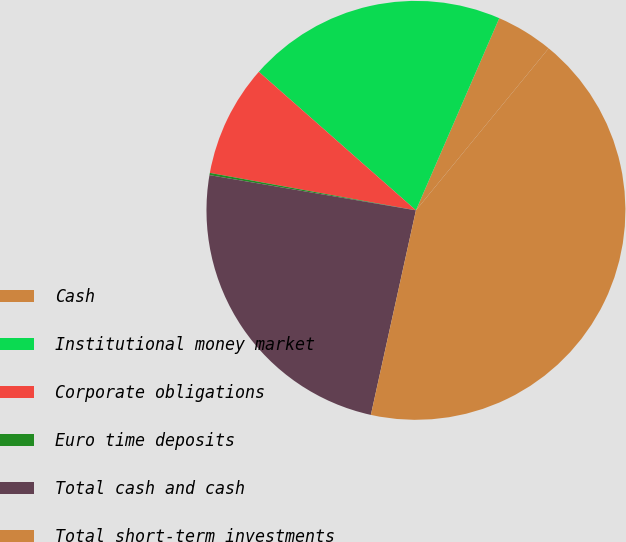Convert chart to OTSL. <chart><loc_0><loc_0><loc_500><loc_500><pie_chart><fcel>Cash<fcel>Institutional money market<fcel>Corporate obligations<fcel>Euro time deposits<fcel>Total cash and cash<fcel>Total short-term investments<nl><fcel>4.41%<fcel>20.01%<fcel>8.64%<fcel>0.17%<fcel>24.24%<fcel>42.53%<nl></chart> 